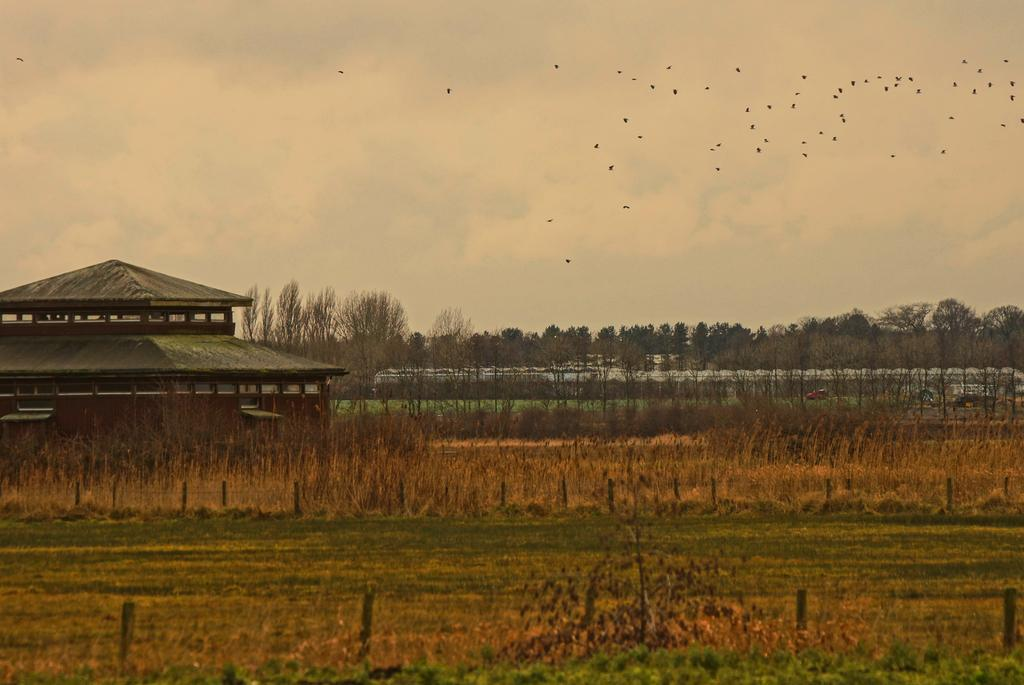What type of vegetation can be seen in the image? There is grass in the image. What type of structure is present in the image? There is a shed in the image. What type of barrier can be seen in the image? There is a fence in the image. What type of natural feature is present in the image? There are trees in the image. What type of transportation is visible in the image? There are vehicles on the road in the image. What type of wildlife can be seen in the image? Flocks of birds are visible at the top of the image. What part of the natural environment is visible in the image? The sky is visible at the top of the image. What time of day does the image appear to be taken? The image appears to be taken during the day. How much attention does the shoe receive in the image? There is no shoe present in the image, so it cannot receive any attention. What type of debt is being discussed in the image? There is no discussion of debt in the image, as it features a scene with grass, a shed, a fence, trees, vehicles, birds, and the sky. 